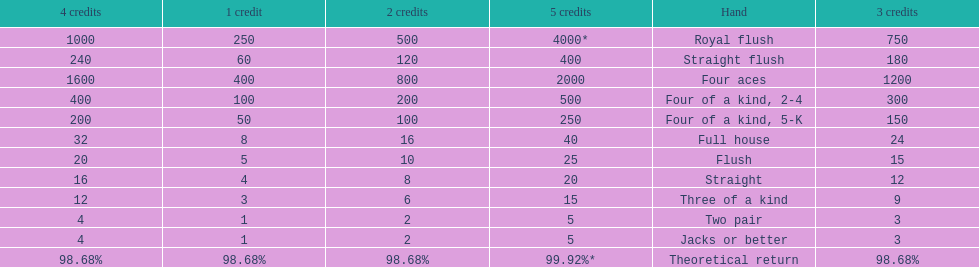Is a 2 credit full house the same as a 5 credit three of a kind? No. 